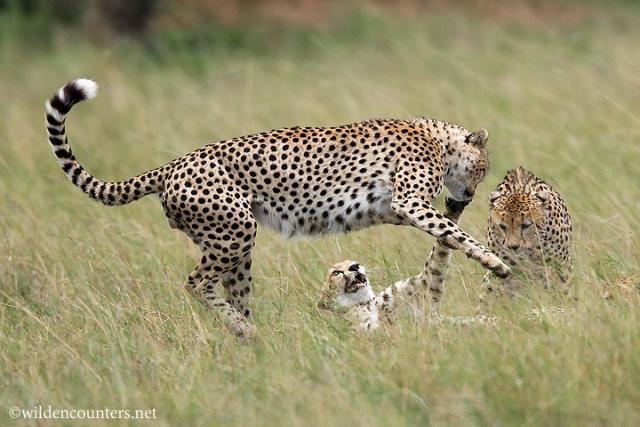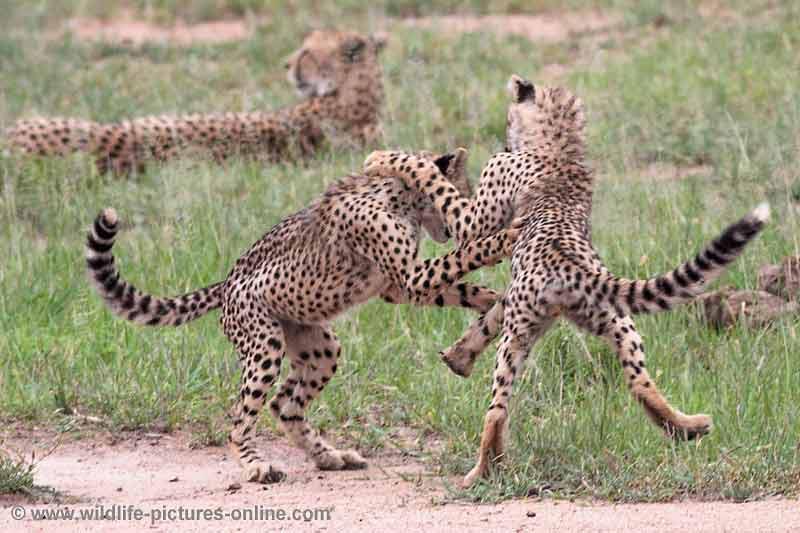The first image is the image on the left, the second image is the image on the right. Considering the images on both sides, is "there are more than 4 cheetahs in the image pair" valid? Answer yes or no. Yes. The first image is the image on the left, the second image is the image on the right. Assess this claim about the two images: "In one image there is an adult cheetah standing over two younger cheetahs.". Correct or not? Answer yes or no. Yes. 